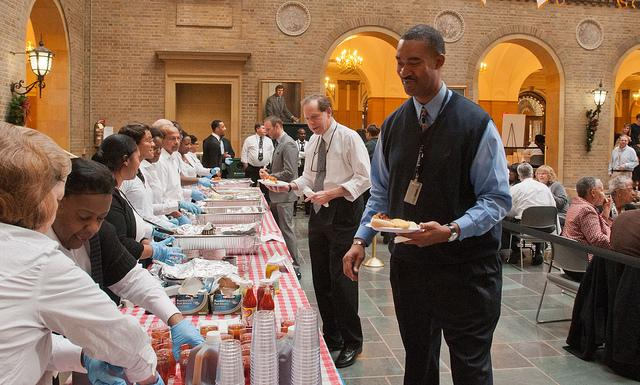Why should they wear gloves? Please explain your reasoning. hygiene. These plastic gloves protect food from germs 